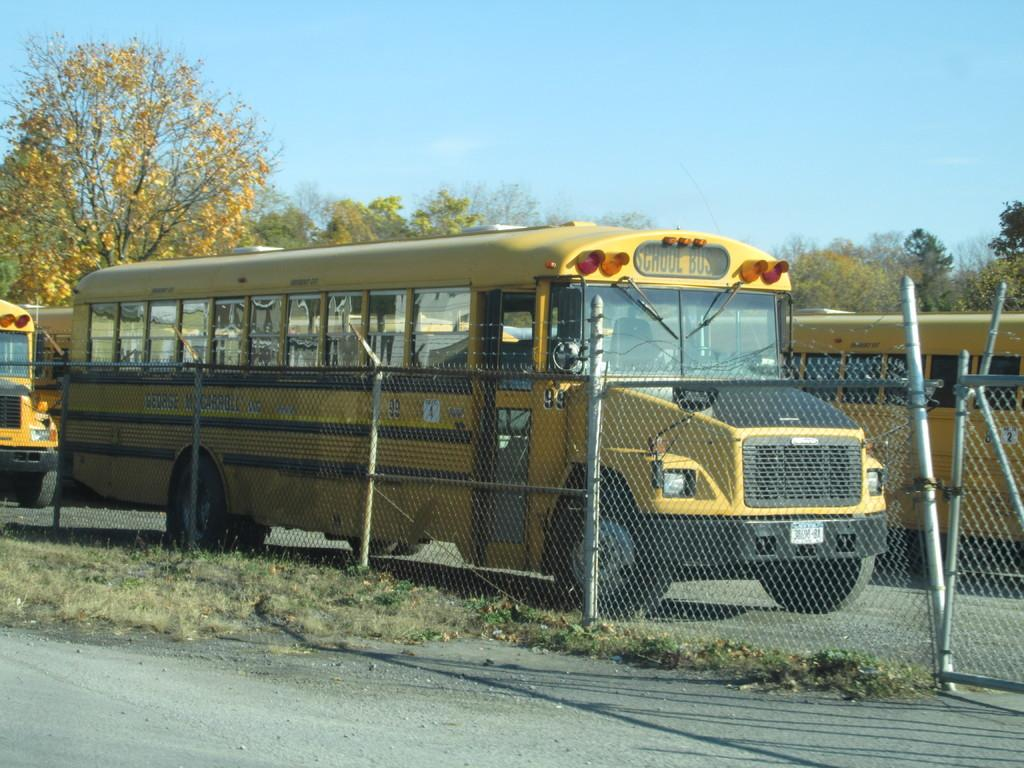<image>
Describe the image concisely. The yellow school bus ihas number 99 on the side. 